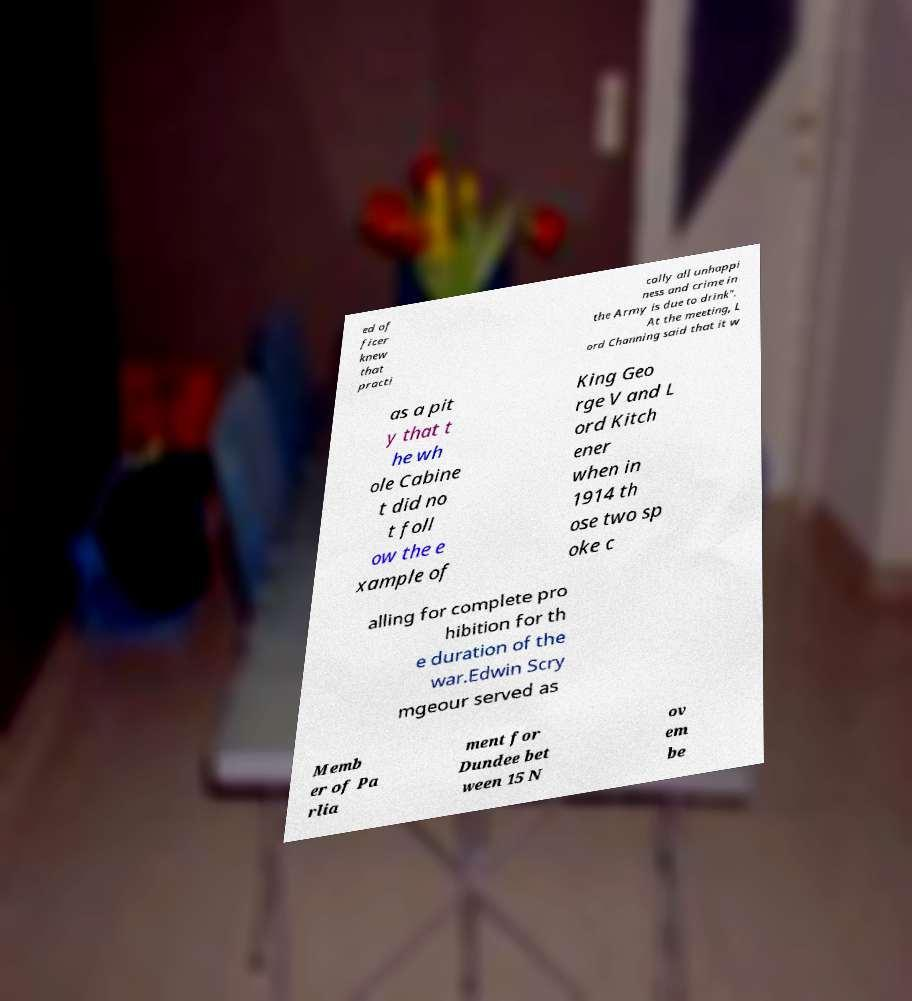Can you accurately transcribe the text from the provided image for me? ed of ficer knew that practi cally all unhappi ness and crime in the Army is due to drink". At the meeting, L ord Channing said that it w as a pit y that t he wh ole Cabine t did no t foll ow the e xample of King Geo rge V and L ord Kitch ener when in 1914 th ose two sp oke c alling for complete pro hibition for th e duration of the war.Edwin Scry mgeour served as Memb er of Pa rlia ment for Dundee bet ween 15 N ov em be 